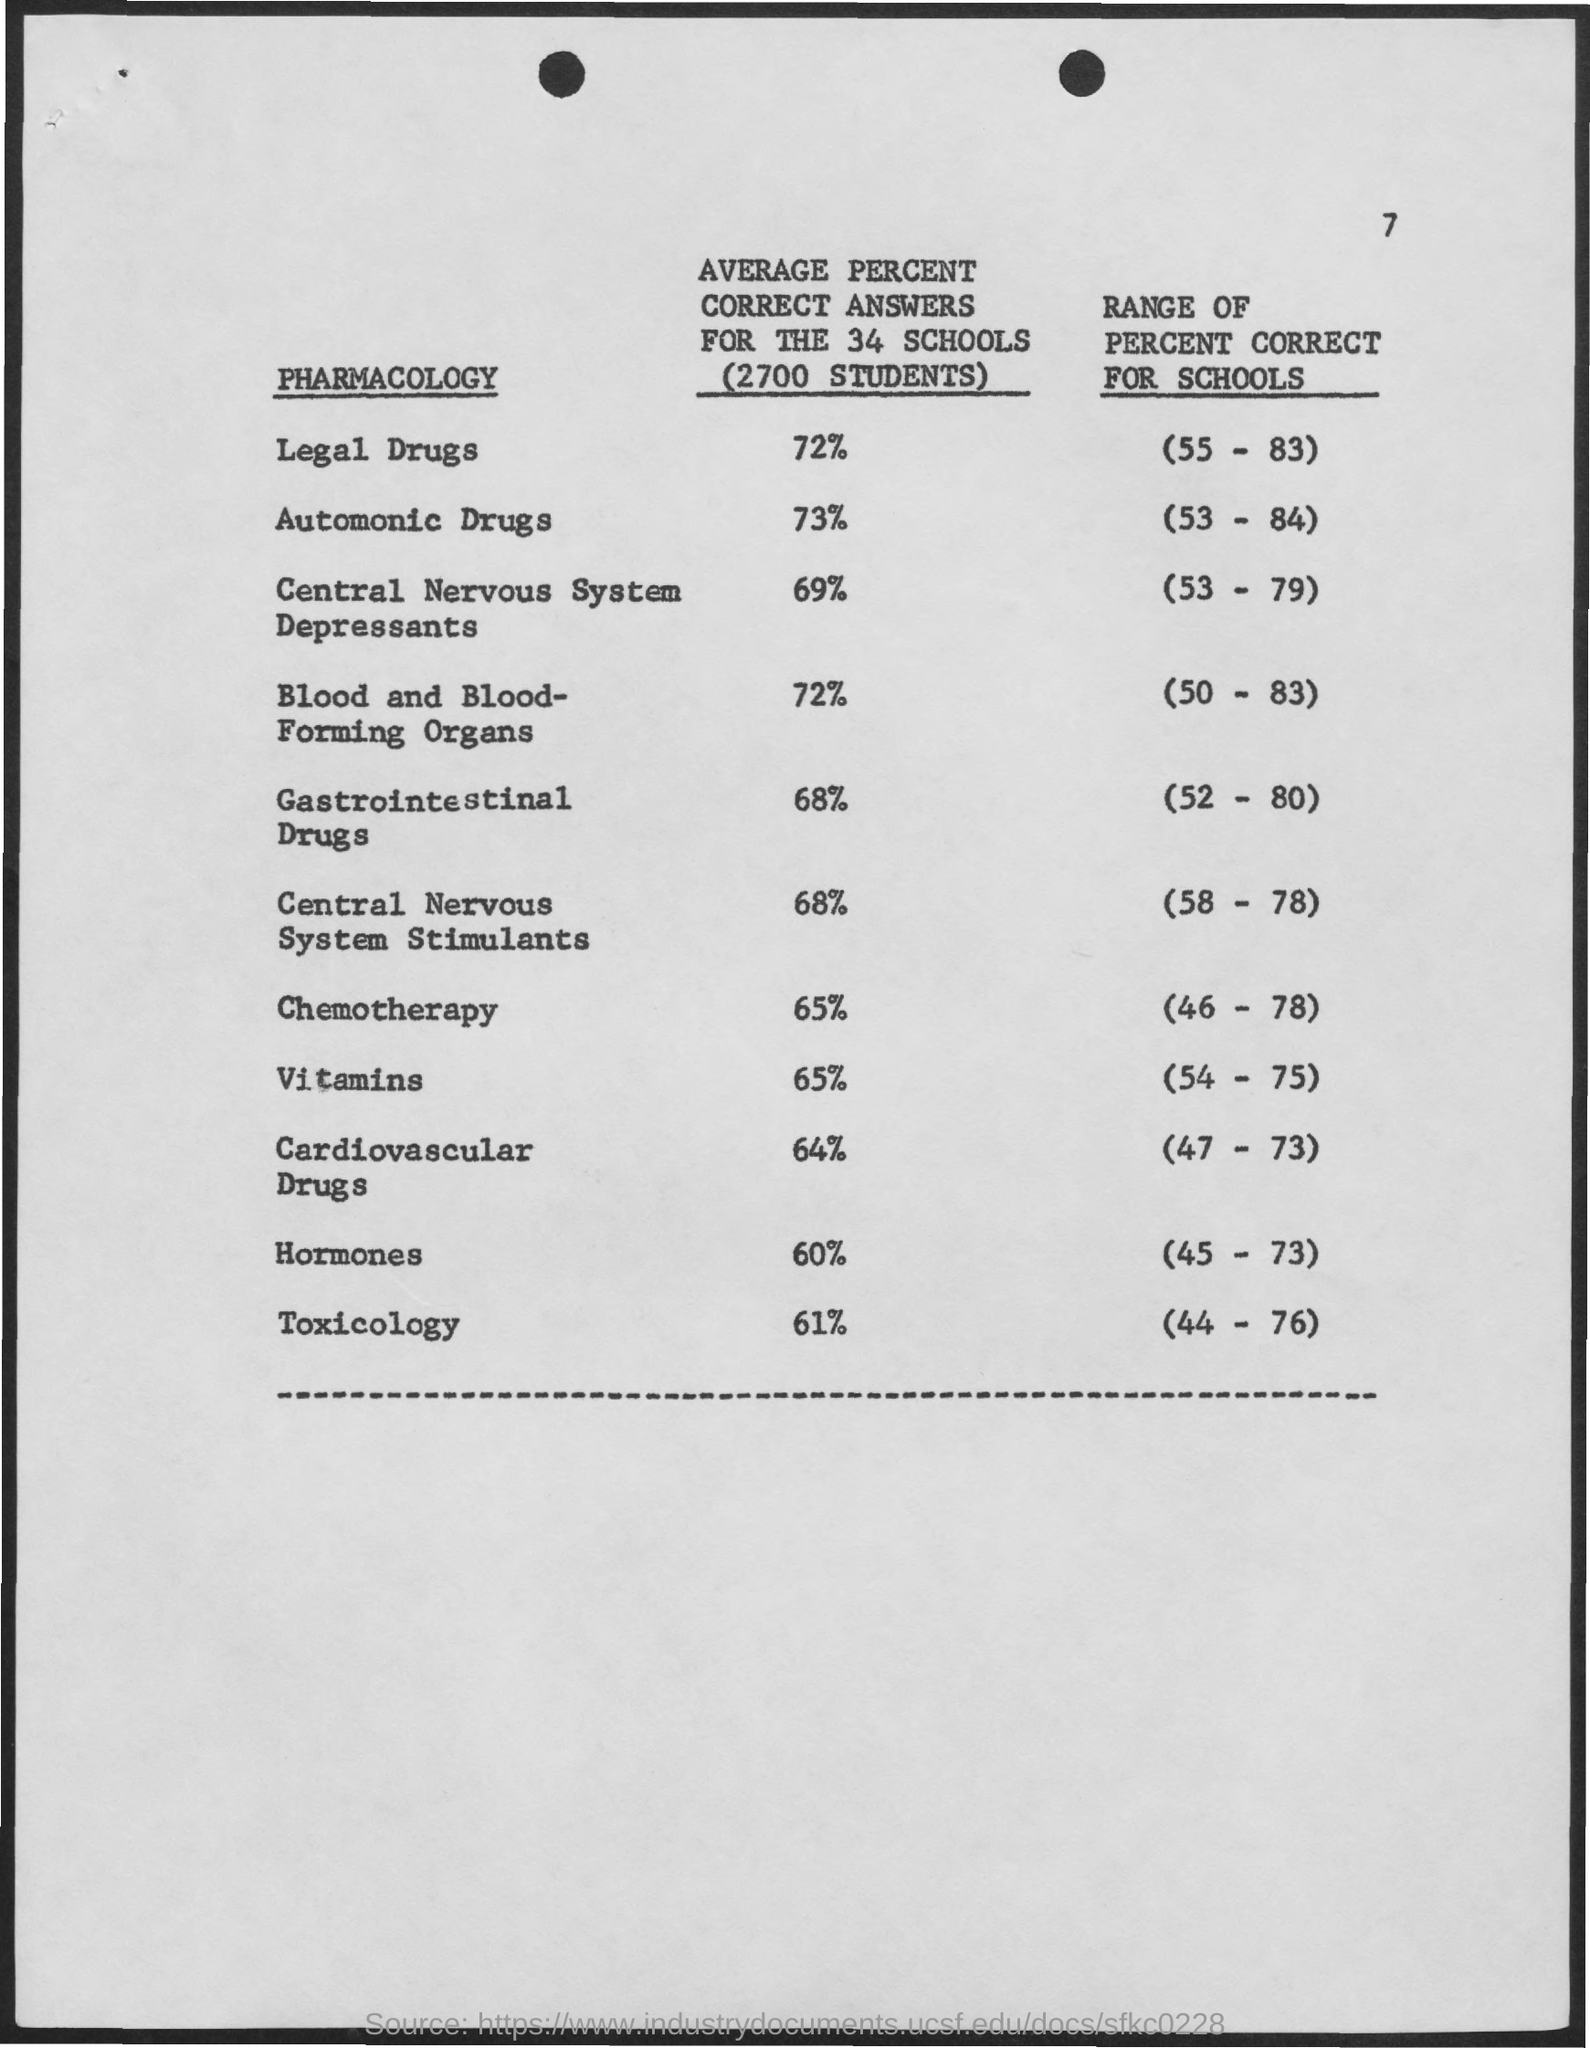What is the average percent correct answers for the 34 schools (2700 students) for Legal Drugs?
Offer a terse response. 72%. What is the average percent correct answers for the 34 schools (2700 students) for Automonic Drugs?
Provide a succinct answer. 73%. What is the average percent correct answers for the 34 schools (2700 students) for Central nervous system depressants?
Offer a terse response. 69%. What is the average percent correct answers for the 34 schools (2700 students) for Blood and blood forming organs?
Ensure brevity in your answer.  72%. What is the average percent correct answers for the 34 schools (2700 students) for Gastrointestinal Drugs?
Provide a succinct answer. 68%. What is the average percent correct answers for the 34 schools (2700 students) for Central Nervous System Stimulants?
Offer a very short reply. 68%. What is the average percent correct answers for the 34 schools (2700 students) for chemotherapy?
Offer a terse response. 65%. What is the average percent correct answers for the 34 schools (2700 students) for Vitamins?
Keep it short and to the point. 65%. What is the average percent correct answers for the 34 schools (2700 students) for Cardiovascular Drugs?
Give a very brief answer. 64%. What is the average percent correct answers for the 34 schools (2700 students) for Hormones?
Provide a short and direct response. 60%. 